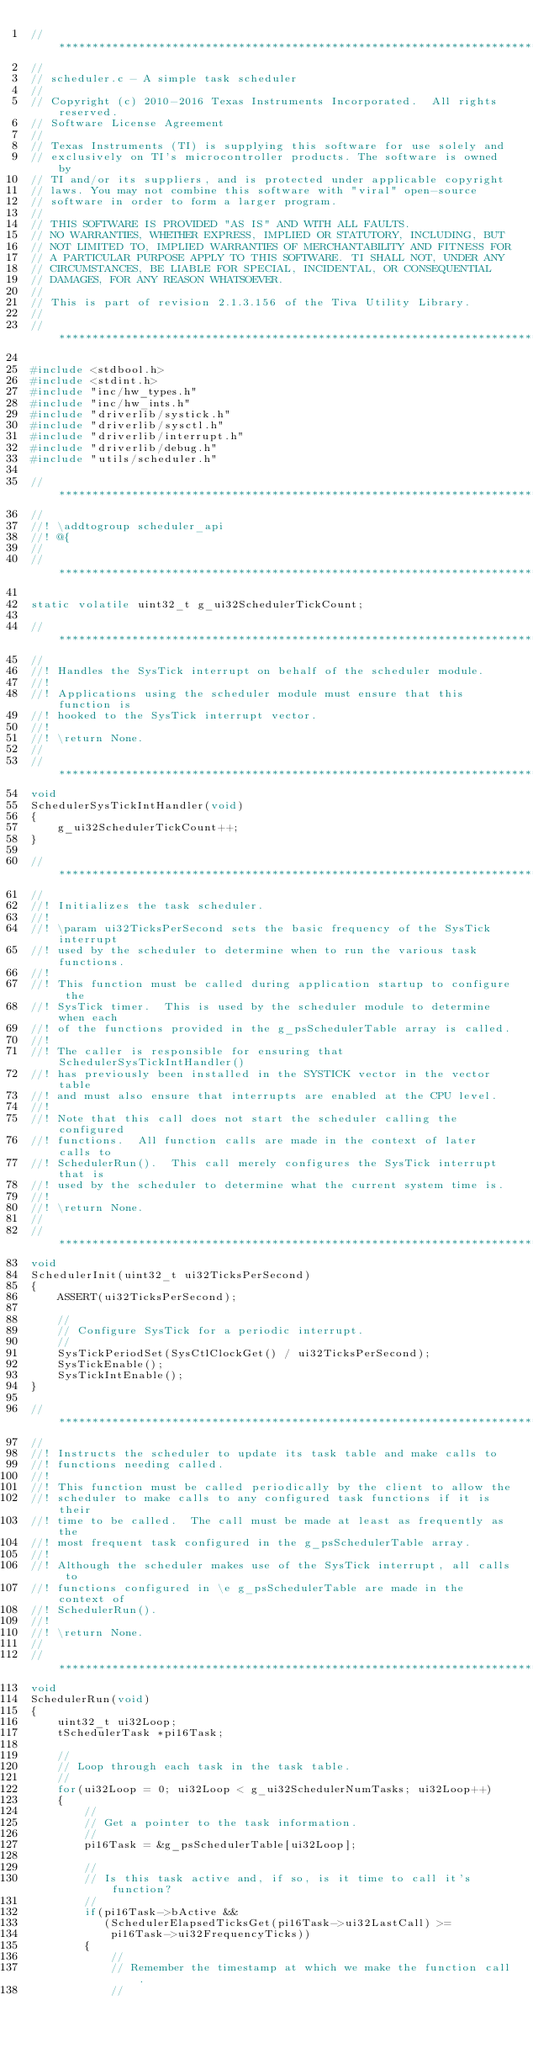<code> <loc_0><loc_0><loc_500><loc_500><_C_>//*****************************************************************************
//
// scheduler.c - A simple task scheduler
//
// Copyright (c) 2010-2016 Texas Instruments Incorporated.  All rights reserved.
// Software License Agreement
// 
// Texas Instruments (TI) is supplying this software for use solely and
// exclusively on TI's microcontroller products. The software is owned by
// TI and/or its suppliers, and is protected under applicable copyright
// laws. You may not combine this software with "viral" open-source
// software in order to form a larger program.
// 
// THIS SOFTWARE IS PROVIDED "AS IS" AND WITH ALL FAULTS.
// NO WARRANTIES, WHETHER EXPRESS, IMPLIED OR STATUTORY, INCLUDING, BUT
// NOT LIMITED TO, IMPLIED WARRANTIES OF MERCHANTABILITY AND FITNESS FOR
// A PARTICULAR PURPOSE APPLY TO THIS SOFTWARE. TI SHALL NOT, UNDER ANY
// CIRCUMSTANCES, BE LIABLE FOR SPECIAL, INCIDENTAL, OR CONSEQUENTIAL
// DAMAGES, FOR ANY REASON WHATSOEVER.
// 
// This is part of revision 2.1.3.156 of the Tiva Utility Library.
//
//*****************************************************************************

#include <stdbool.h>
#include <stdint.h>
#include "inc/hw_types.h"
#include "inc/hw_ints.h"
#include "driverlib/systick.h"
#include "driverlib/sysctl.h"
#include "driverlib/interrupt.h"
#include "driverlib/debug.h"
#include "utils/scheduler.h"

//*****************************************************************************
//
//! \addtogroup scheduler_api
//! @{
//
//*****************************************************************************

static volatile uint32_t g_ui32SchedulerTickCount;

//*****************************************************************************
//
//! Handles the SysTick interrupt on behalf of the scheduler module.
//!
//! Applications using the scheduler module must ensure that this function is
//! hooked to the SysTick interrupt vector.
//!
//! \return None.
//
//*****************************************************************************
void
SchedulerSysTickIntHandler(void)
{
    g_ui32SchedulerTickCount++;
}

//*****************************************************************************
//
//! Initializes the task scheduler.
//!
//! \param ui32TicksPerSecond sets the basic frequency of the SysTick interrupt
//! used by the scheduler to determine when to run the various task functions.
//!
//! This function must be called during application startup to configure the
//! SysTick timer.  This is used by the scheduler module to determine when each
//! of the functions provided in the g_psSchedulerTable array is called.
//!
//! The caller is responsible for ensuring that SchedulerSysTickIntHandler()
//! has previously been installed in the SYSTICK vector in the vector table
//! and must also ensure that interrupts are enabled at the CPU level.
//!
//! Note that this call does not start the scheduler calling the configured
//! functions.  All function calls are made in the context of later calls to
//! SchedulerRun().  This call merely configures the SysTick interrupt that is
//! used by the scheduler to determine what the current system time is.
//!
//! \return None.
//
//*****************************************************************************
void
SchedulerInit(uint32_t ui32TicksPerSecond)
{
    ASSERT(ui32TicksPerSecond);

    //
    // Configure SysTick for a periodic interrupt.
    //
    SysTickPeriodSet(SysCtlClockGet() / ui32TicksPerSecond);
    SysTickEnable();
    SysTickIntEnable();
}

//*****************************************************************************
//
//! Instructs the scheduler to update its task table and make calls to
//! functions needing called.
//!
//! This function must be called periodically by the client to allow the
//! scheduler to make calls to any configured task functions if it is their
//! time to be called.  The call must be made at least as frequently as the
//! most frequent task configured in the g_psSchedulerTable array.
//!
//! Although the scheduler makes use of the SysTick interrupt, all calls to
//! functions configured in \e g_psSchedulerTable are made in the context of
//! SchedulerRun().
//!
//! \return None.
//
//*****************************************************************************
void
SchedulerRun(void)
{
    uint32_t ui32Loop;
    tSchedulerTask *pi16Task;

    //
    // Loop through each task in the task table.
    //
    for(ui32Loop = 0; ui32Loop < g_ui32SchedulerNumTasks; ui32Loop++)
    {
        //
        // Get a pointer to the task information.
        //
        pi16Task = &g_psSchedulerTable[ui32Loop];

        //
        // Is this task active and, if so, is it time to call it's function?
        //
        if(pi16Task->bActive &&
           (SchedulerElapsedTicksGet(pi16Task->ui32LastCall) >=
            pi16Task->ui32FrequencyTicks))
        {
            //
            // Remember the timestamp at which we make the function call.
            //</code> 